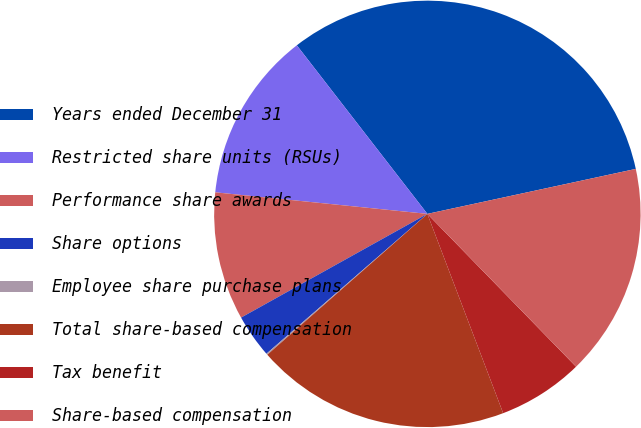<chart> <loc_0><loc_0><loc_500><loc_500><pie_chart><fcel>Years ended December 31<fcel>Restricted share units (RSUs)<fcel>Performance share awards<fcel>Share options<fcel>Employee share purchase plans<fcel>Total share-based compensation<fcel>Tax benefit<fcel>Share-based compensation<nl><fcel>32.11%<fcel>12.9%<fcel>9.7%<fcel>3.3%<fcel>0.1%<fcel>19.3%<fcel>6.5%<fcel>16.1%<nl></chart> 